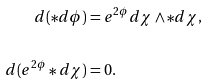Convert formula to latex. <formula><loc_0><loc_0><loc_500><loc_500>d ( \ast d \phi ) & = e ^ { 2 \phi } d \chi \wedge \ast d \chi , \\ \\ d ( e ^ { 2 \phi } \ast d \chi ) & = 0 .</formula> 